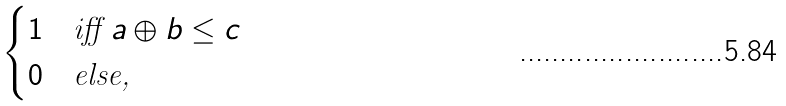<formula> <loc_0><loc_0><loc_500><loc_500>\begin{cases} 1 & \text {iff } a \oplus b \leq c \\ 0 & \text {else,} \end{cases}</formula> 